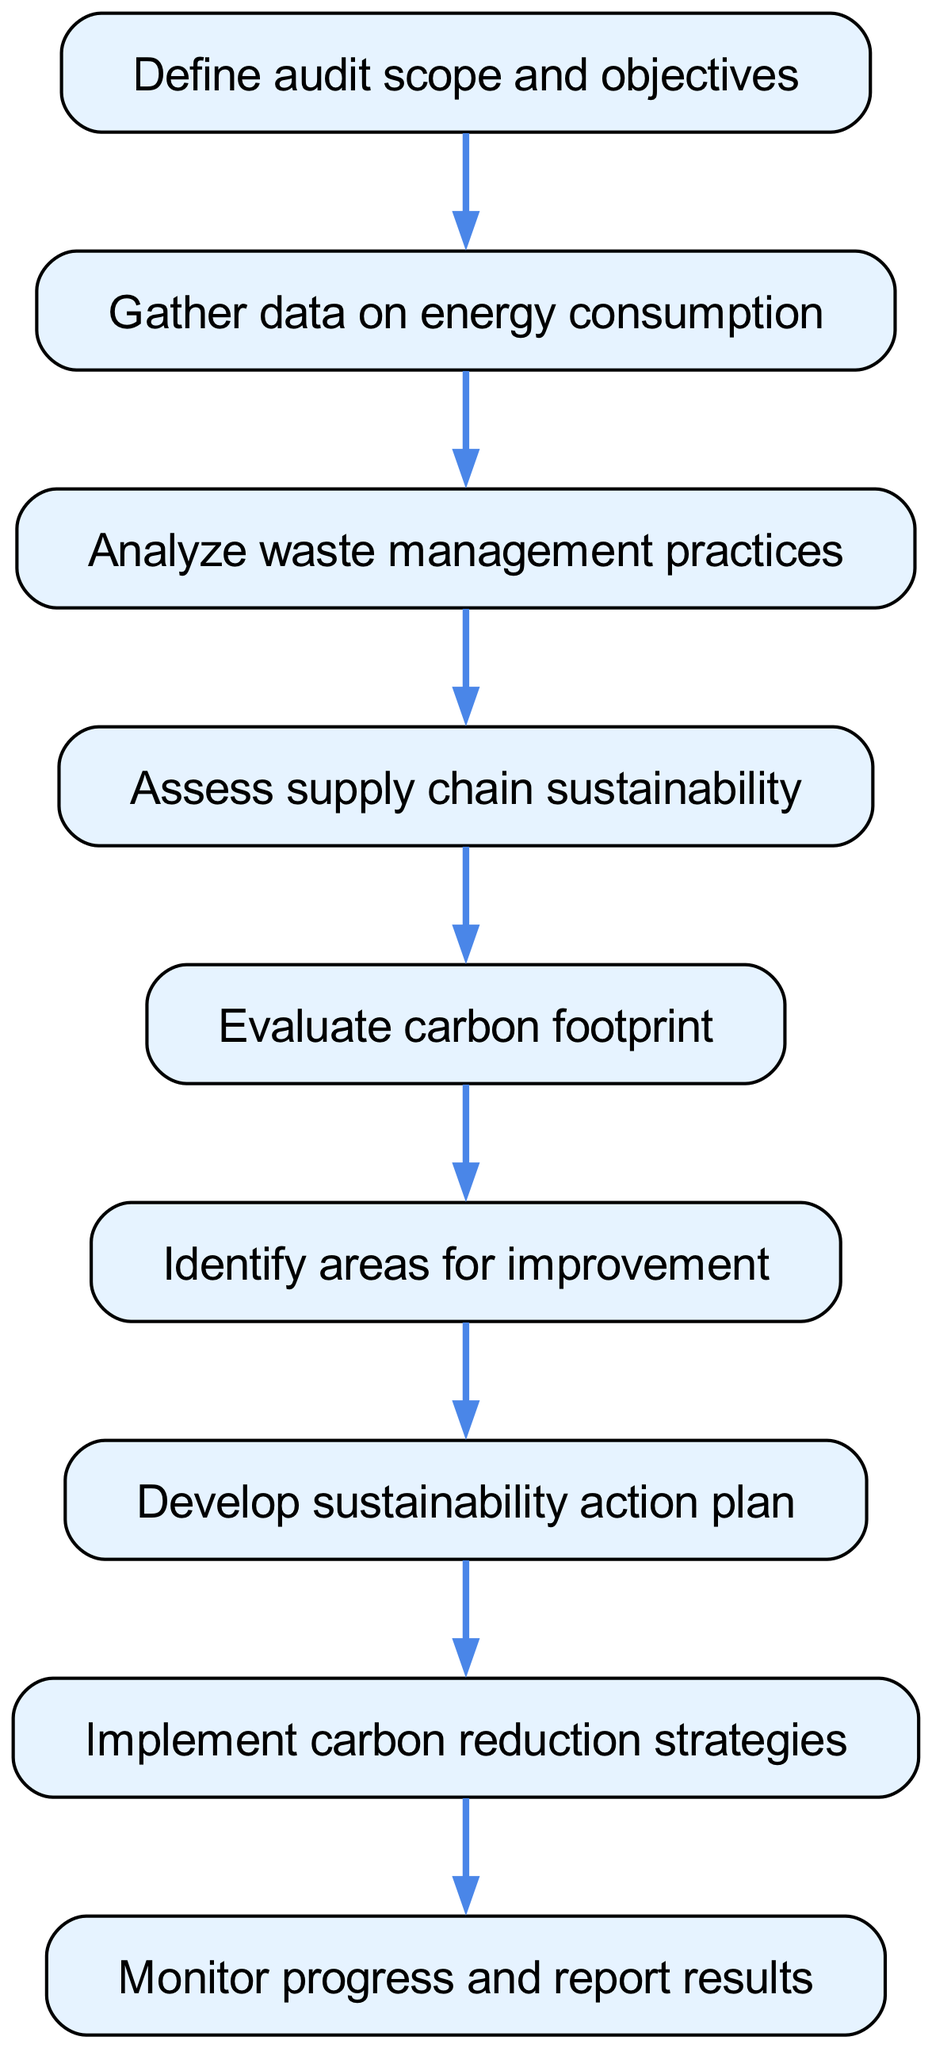What is the first step in the sustainability audit process? The first step in the process is defined as "Define audit scope and objectives", which can be found at the top of the flowchart.
Answer: Define audit scope and objectives How many steps are there in total in the sustainability audit process? By counting the nodes in the flowchart, there are a total of nine distinct steps present in the process.
Answer: Nine What step comes after analyzing waste management practices? The step that follows "Analyze waste management practices" is "Assess supply chain sustainability", which is the direct connection in the flow.
Answer: Assess supply chain sustainability Which step involves evaluating the carbon footprint? The step that specifically mentions "Evaluate carbon footprint" is the fifth step in the sequence of the audit process.
Answer: Evaluate carbon footprint What is the final action taken in the sustainability audit process? The last action listed in the diagram is "Monitor progress and report results", indicating that this is the concluding step of the audit process.
Answer: Monitor progress and report results Which steps lead to the development of a sustainability action plan? The steps leading to the "Develop sustainability action plan" are "Identify areas for improvement" and "Evaluate carbon footprint", forming an essential path through the audit process.
Answer: Identify areas for improvement, Evaluate carbon footprint If a business correctly follows each step sequentially, how should they conclude their audit? The conclusion of the audit process is carried out by the final step, which is to "Monitor progress and report results", representing the wrap-up of their sustainability efforts.
Answer: Monitor progress and report results 